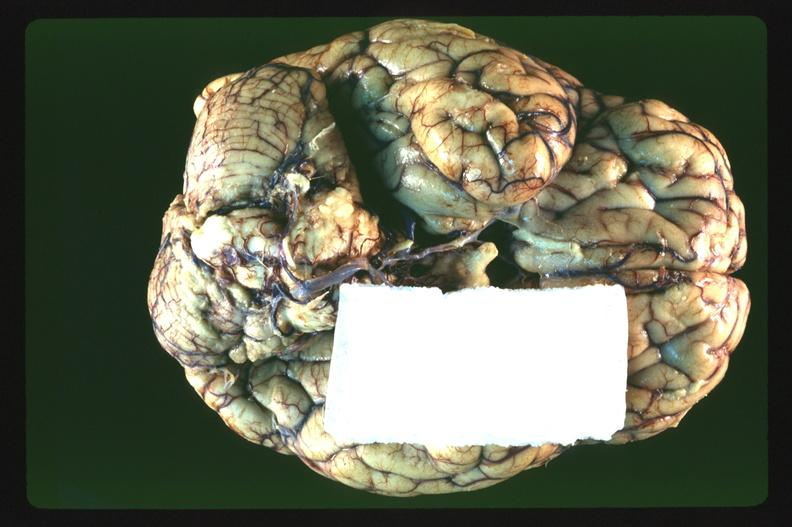s nervous present?
Answer the question using a single word or phrase. Yes 